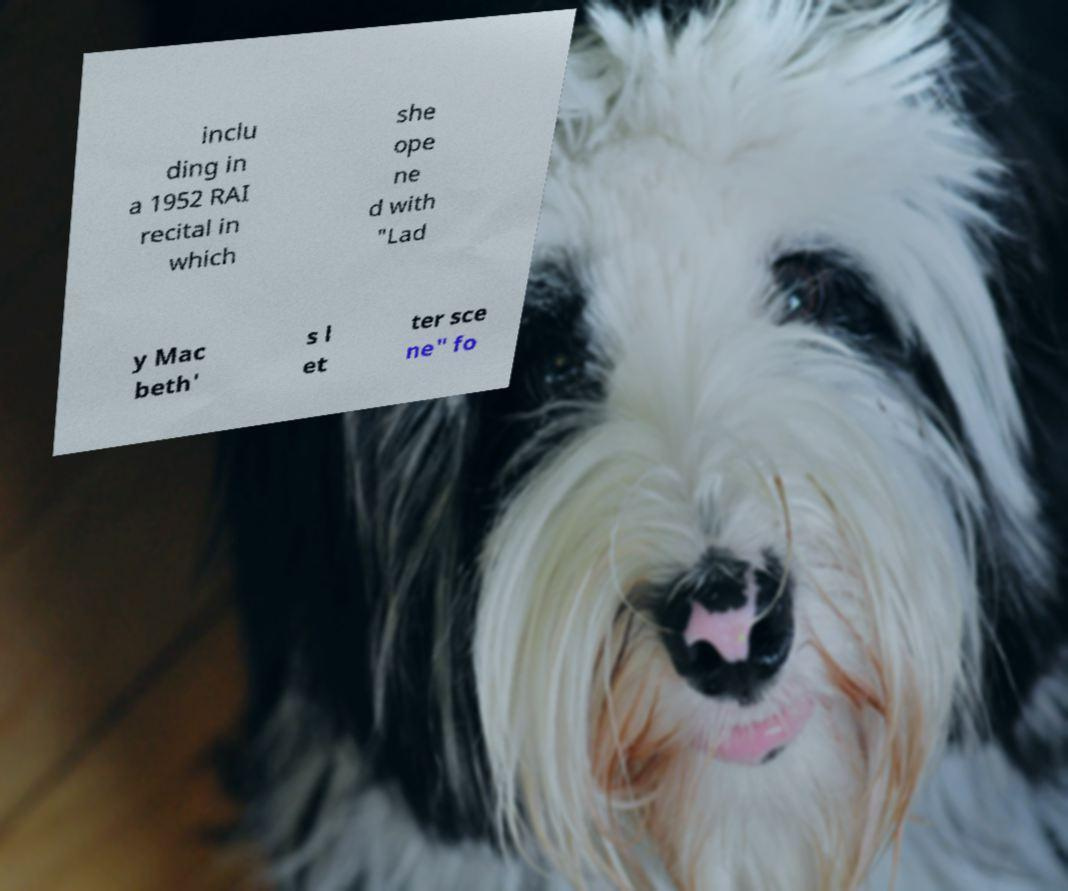I need the written content from this picture converted into text. Can you do that? inclu ding in a 1952 RAI recital in which she ope ne d with "Lad y Mac beth' s l et ter sce ne" fo 